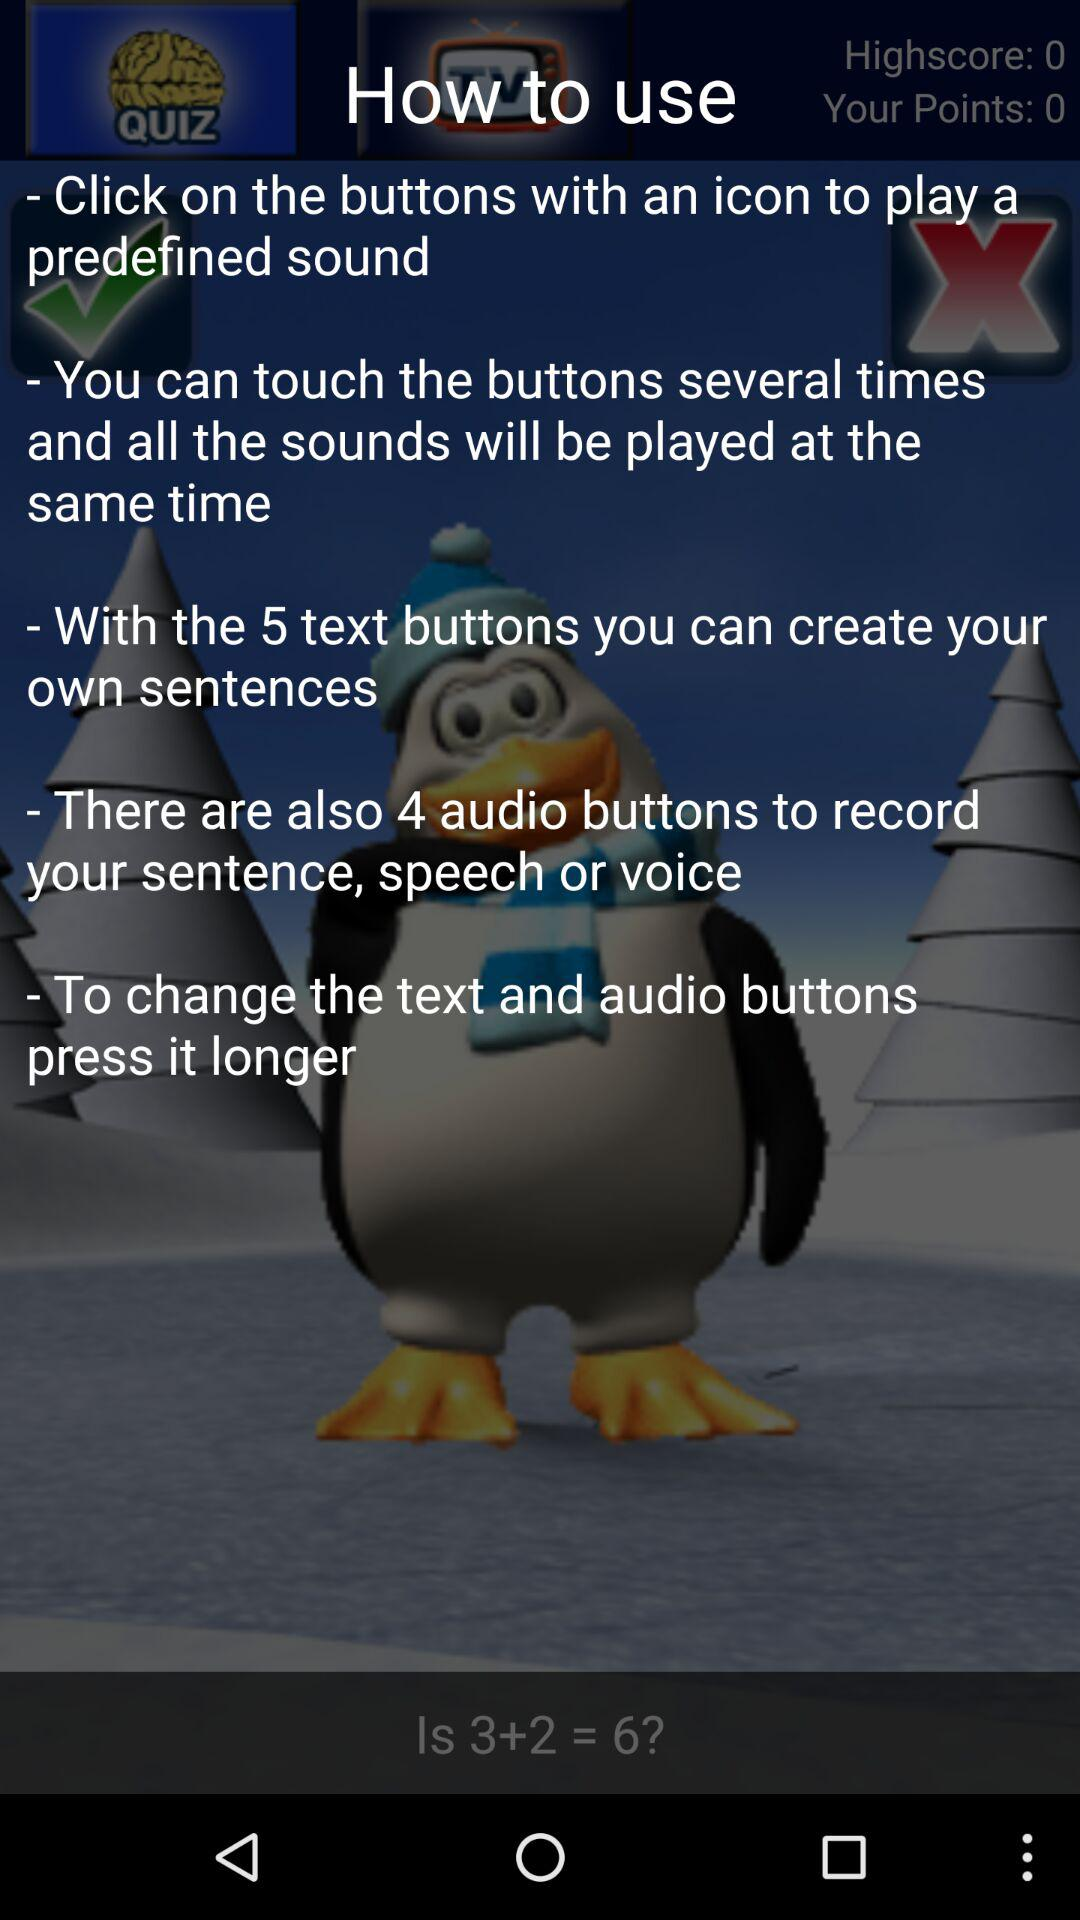How many text buttons are used to create a user's own sentences? There are 5 text buttons used to create a user's own sentences. 